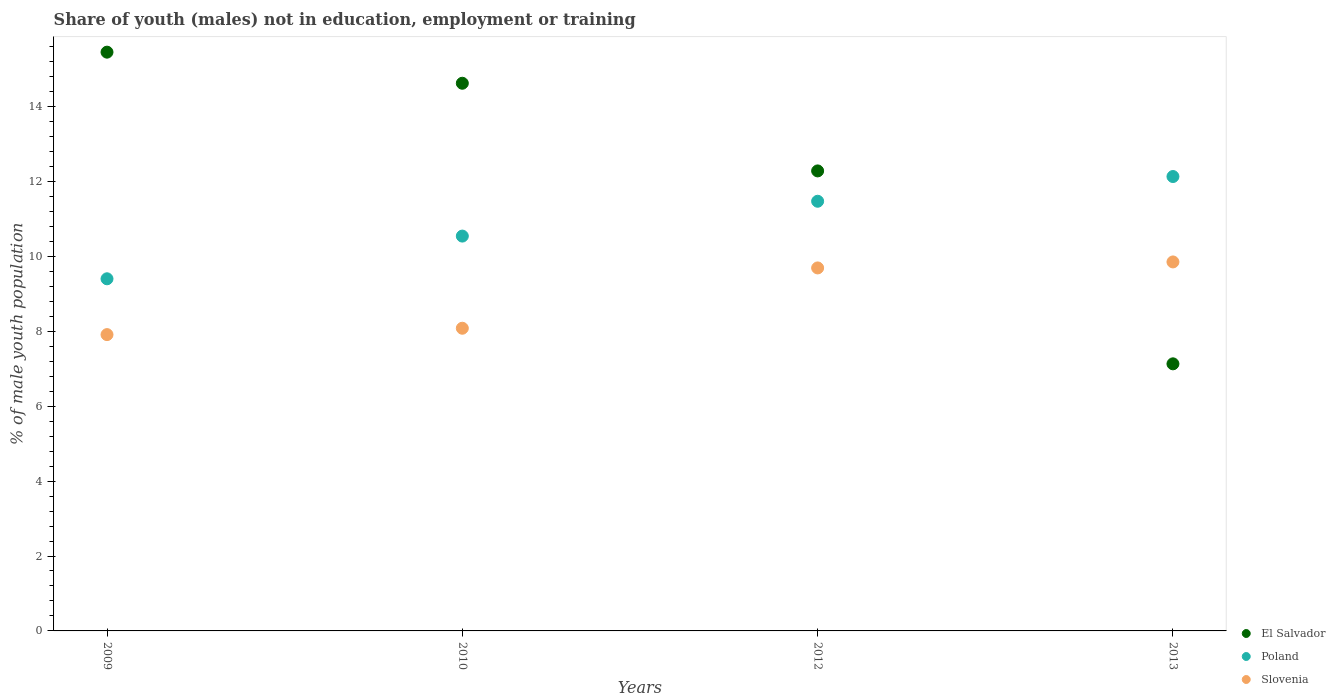Is the number of dotlines equal to the number of legend labels?
Give a very brief answer. Yes. What is the percentage of unemployed males population in in Slovenia in 2009?
Provide a short and direct response. 7.91. Across all years, what is the maximum percentage of unemployed males population in in Slovenia?
Provide a short and direct response. 9.85. Across all years, what is the minimum percentage of unemployed males population in in El Salvador?
Make the answer very short. 7.13. In which year was the percentage of unemployed males population in in Slovenia maximum?
Provide a short and direct response. 2013. In which year was the percentage of unemployed males population in in Poland minimum?
Your response must be concise. 2009. What is the total percentage of unemployed males population in in El Salvador in the graph?
Make the answer very short. 49.48. What is the difference between the percentage of unemployed males population in in Poland in 2009 and that in 2010?
Provide a short and direct response. -1.14. What is the difference between the percentage of unemployed males population in in Poland in 2013 and the percentage of unemployed males population in in El Salvador in 2009?
Your answer should be very brief. -3.32. What is the average percentage of unemployed males population in in El Salvador per year?
Your response must be concise. 12.37. In the year 2012, what is the difference between the percentage of unemployed males population in in Slovenia and percentage of unemployed males population in in Poland?
Your answer should be compact. -1.78. In how many years, is the percentage of unemployed males population in in Slovenia greater than 10.4 %?
Your answer should be compact. 0. What is the ratio of the percentage of unemployed males population in in Poland in 2010 to that in 2013?
Provide a short and direct response. 0.87. Is the percentage of unemployed males population in in Slovenia in 2010 less than that in 2012?
Give a very brief answer. Yes. What is the difference between the highest and the second highest percentage of unemployed males population in in Poland?
Offer a terse response. 0.66. What is the difference between the highest and the lowest percentage of unemployed males population in in Slovenia?
Provide a short and direct response. 1.94. In how many years, is the percentage of unemployed males population in in Slovenia greater than the average percentage of unemployed males population in in Slovenia taken over all years?
Make the answer very short. 2. Is the sum of the percentage of unemployed males population in in El Salvador in 2010 and 2012 greater than the maximum percentage of unemployed males population in in Poland across all years?
Make the answer very short. Yes. Is it the case that in every year, the sum of the percentage of unemployed males population in in Poland and percentage of unemployed males population in in Slovenia  is greater than the percentage of unemployed males population in in El Salvador?
Keep it short and to the point. Yes. Is the percentage of unemployed males population in in El Salvador strictly greater than the percentage of unemployed males population in in Poland over the years?
Your response must be concise. No. What is the difference between two consecutive major ticks on the Y-axis?
Make the answer very short. 2. Does the graph contain any zero values?
Keep it short and to the point. No. How many legend labels are there?
Offer a terse response. 3. How are the legend labels stacked?
Your answer should be very brief. Vertical. What is the title of the graph?
Your answer should be very brief. Share of youth (males) not in education, employment or training. What is the label or title of the Y-axis?
Offer a very short reply. % of male youth population. What is the % of male youth population of El Salvador in 2009?
Provide a succinct answer. 15.45. What is the % of male youth population in Poland in 2009?
Keep it short and to the point. 9.4. What is the % of male youth population in Slovenia in 2009?
Ensure brevity in your answer.  7.91. What is the % of male youth population in El Salvador in 2010?
Provide a succinct answer. 14.62. What is the % of male youth population of Poland in 2010?
Offer a terse response. 10.54. What is the % of male youth population in Slovenia in 2010?
Provide a succinct answer. 8.08. What is the % of male youth population of El Salvador in 2012?
Ensure brevity in your answer.  12.28. What is the % of male youth population of Poland in 2012?
Ensure brevity in your answer.  11.47. What is the % of male youth population in Slovenia in 2012?
Your answer should be very brief. 9.69. What is the % of male youth population of El Salvador in 2013?
Your response must be concise. 7.13. What is the % of male youth population in Poland in 2013?
Your response must be concise. 12.13. What is the % of male youth population in Slovenia in 2013?
Offer a very short reply. 9.85. Across all years, what is the maximum % of male youth population in El Salvador?
Give a very brief answer. 15.45. Across all years, what is the maximum % of male youth population in Poland?
Make the answer very short. 12.13. Across all years, what is the maximum % of male youth population in Slovenia?
Your answer should be compact. 9.85. Across all years, what is the minimum % of male youth population in El Salvador?
Your response must be concise. 7.13. Across all years, what is the minimum % of male youth population in Poland?
Provide a succinct answer. 9.4. Across all years, what is the minimum % of male youth population in Slovenia?
Your response must be concise. 7.91. What is the total % of male youth population of El Salvador in the graph?
Make the answer very short. 49.48. What is the total % of male youth population of Poland in the graph?
Offer a terse response. 43.54. What is the total % of male youth population in Slovenia in the graph?
Ensure brevity in your answer.  35.53. What is the difference between the % of male youth population of El Salvador in 2009 and that in 2010?
Provide a succinct answer. 0.83. What is the difference between the % of male youth population of Poland in 2009 and that in 2010?
Keep it short and to the point. -1.14. What is the difference between the % of male youth population in Slovenia in 2009 and that in 2010?
Make the answer very short. -0.17. What is the difference between the % of male youth population in El Salvador in 2009 and that in 2012?
Your answer should be compact. 3.17. What is the difference between the % of male youth population of Poland in 2009 and that in 2012?
Give a very brief answer. -2.07. What is the difference between the % of male youth population in Slovenia in 2009 and that in 2012?
Offer a very short reply. -1.78. What is the difference between the % of male youth population of El Salvador in 2009 and that in 2013?
Provide a succinct answer. 8.32. What is the difference between the % of male youth population in Poland in 2009 and that in 2013?
Provide a succinct answer. -2.73. What is the difference between the % of male youth population in Slovenia in 2009 and that in 2013?
Offer a very short reply. -1.94. What is the difference between the % of male youth population in El Salvador in 2010 and that in 2012?
Offer a very short reply. 2.34. What is the difference between the % of male youth population in Poland in 2010 and that in 2012?
Offer a very short reply. -0.93. What is the difference between the % of male youth population in Slovenia in 2010 and that in 2012?
Offer a very short reply. -1.61. What is the difference between the % of male youth population of El Salvador in 2010 and that in 2013?
Your answer should be compact. 7.49. What is the difference between the % of male youth population in Poland in 2010 and that in 2013?
Ensure brevity in your answer.  -1.59. What is the difference between the % of male youth population in Slovenia in 2010 and that in 2013?
Keep it short and to the point. -1.77. What is the difference between the % of male youth population in El Salvador in 2012 and that in 2013?
Keep it short and to the point. 5.15. What is the difference between the % of male youth population in Poland in 2012 and that in 2013?
Make the answer very short. -0.66. What is the difference between the % of male youth population in Slovenia in 2012 and that in 2013?
Your answer should be compact. -0.16. What is the difference between the % of male youth population of El Salvador in 2009 and the % of male youth population of Poland in 2010?
Ensure brevity in your answer.  4.91. What is the difference between the % of male youth population in El Salvador in 2009 and the % of male youth population in Slovenia in 2010?
Ensure brevity in your answer.  7.37. What is the difference between the % of male youth population of Poland in 2009 and the % of male youth population of Slovenia in 2010?
Offer a very short reply. 1.32. What is the difference between the % of male youth population of El Salvador in 2009 and the % of male youth population of Poland in 2012?
Your answer should be compact. 3.98. What is the difference between the % of male youth population of El Salvador in 2009 and the % of male youth population of Slovenia in 2012?
Offer a very short reply. 5.76. What is the difference between the % of male youth population of Poland in 2009 and the % of male youth population of Slovenia in 2012?
Provide a succinct answer. -0.29. What is the difference between the % of male youth population in El Salvador in 2009 and the % of male youth population in Poland in 2013?
Your answer should be compact. 3.32. What is the difference between the % of male youth population in Poland in 2009 and the % of male youth population in Slovenia in 2013?
Give a very brief answer. -0.45. What is the difference between the % of male youth population in El Salvador in 2010 and the % of male youth population in Poland in 2012?
Give a very brief answer. 3.15. What is the difference between the % of male youth population of El Salvador in 2010 and the % of male youth population of Slovenia in 2012?
Offer a very short reply. 4.93. What is the difference between the % of male youth population of El Salvador in 2010 and the % of male youth population of Poland in 2013?
Give a very brief answer. 2.49. What is the difference between the % of male youth population of El Salvador in 2010 and the % of male youth population of Slovenia in 2013?
Give a very brief answer. 4.77. What is the difference between the % of male youth population of Poland in 2010 and the % of male youth population of Slovenia in 2013?
Your answer should be compact. 0.69. What is the difference between the % of male youth population in El Salvador in 2012 and the % of male youth population in Poland in 2013?
Provide a short and direct response. 0.15. What is the difference between the % of male youth population in El Salvador in 2012 and the % of male youth population in Slovenia in 2013?
Make the answer very short. 2.43. What is the difference between the % of male youth population in Poland in 2012 and the % of male youth population in Slovenia in 2013?
Provide a short and direct response. 1.62. What is the average % of male youth population of El Salvador per year?
Your response must be concise. 12.37. What is the average % of male youth population of Poland per year?
Make the answer very short. 10.88. What is the average % of male youth population of Slovenia per year?
Ensure brevity in your answer.  8.88. In the year 2009, what is the difference between the % of male youth population of El Salvador and % of male youth population of Poland?
Your answer should be compact. 6.05. In the year 2009, what is the difference between the % of male youth population of El Salvador and % of male youth population of Slovenia?
Offer a terse response. 7.54. In the year 2009, what is the difference between the % of male youth population of Poland and % of male youth population of Slovenia?
Provide a short and direct response. 1.49. In the year 2010, what is the difference between the % of male youth population of El Salvador and % of male youth population of Poland?
Your answer should be compact. 4.08. In the year 2010, what is the difference between the % of male youth population in El Salvador and % of male youth population in Slovenia?
Your response must be concise. 6.54. In the year 2010, what is the difference between the % of male youth population in Poland and % of male youth population in Slovenia?
Ensure brevity in your answer.  2.46. In the year 2012, what is the difference between the % of male youth population in El Salvador and % of male youth population in Poland?
Give a very brief answer. 0.81. In the year 2012, what is the difference between the % of male youth population in El Salvador and % of male youth population in Slovenia?
Offer a very short reply. 2.59. In the year 2012, what is the difference between the % of male youth population in Poland and % of male youth population in Slovenia?
Your response must be concise. 1.78. In the year 2013, what is the difference between the % of male youth population in El Salvador and % of male youth population in Poland?
Provide a short and direct response. -5. In the year 2013, what is the difference between the % of male youth population in El Salvador and % of male youth population in Slovenia?
Offer a terse response. -2.72. In the year 2013, what is the difference between the % of male youth population in Poland and % of male youth population in Slovenia?
Ensure brevity in your answer.  2.28. What is the ratio of the % of male youth population of El Salvador in 2009 to that in 2010?
Ensure brevity in your answer.  1.06. What is the ratio of the % of male youth population of Poland in 2009 to that in 2010?
Your response must be concise. 0.89. What is the ratio of the % of male youth population in El Salvador in 2009 to that in 2012?
Provide a succinct answer. 1.26. What is the ratio of the % of male youth population of Poland in 2009 to that in 2012?
Keep it short and to the point. 0.82. What is the ratio of the % of male youth population in Slovenia in 2009 to that in 2012?
Offer a terse response. 0.82. What is the ratio of the % of male youth population of El Salvador in 2009 to that in 2013?
Your response must be concise. 2.17. What is the ratio of the % of male youth population in Poland in 2009 to that in 2013?
Your answer should be very brief. 0.77. What is the ratio of the % of male youth population in Slovenia in 2009 to that in 2013?
Make the answer very short. 0.8. What is the ratio of the % of male youth population of El Salvador in 2010 to that in 2012?
Provide a short and direct response. 1.19. What is the ratio of the % of male youth population of Poland in 2010 to that in 2012?
Give a very brief answer. 0.92. What is the ratio of the % of male youth population in Slovenia in 2010 to that in 2012?
Ensure brevity in your answer.  0.83. What is the ratio of the % of male youth population in El Salvador in 2010 to that in 2013?
Ensure brevity in your answer.  2.05. What is the ratio of the % of male youth population in Poland in 2010 to that in 2013?
Give a very brief answer. 0.87. What is the ratio of the % of male youth population in Slovenia in 2010 to that in 2013?
Provide a succinct answer. 0.82. What is the ratio of the % of male youth population of El Salvador in 2012 to that in 2013?
Give a very brief answer. 1.72. What is the ratio of the % of male youth population of Poland in 2012 to that in 2013?
Provide a succinct answer. 0.95. What is the ratio of the % of male youth population of Slovenia in 2012 to that in 2013?
Offer a terse response. 0.98. What is the difference between the highest and the second highest % of male youth population of El Salvador?
Your answer should be compact. 0.83. What is the difference between the highest and the second highest % of male youth population of Poland?
Provide a short and direct response. 0.66. What is the difference between the highest and the second highest % of male youth population in Slovenia?
Offer a very short reply. 0.16. What is the difference between the highest and the lowest % of male youth population in El Salvador?
Provide a succinct answer. 8.32. What is the difference between the highest and the lowest % of male youth population of Poland?
Your response must be concise. 2.73. What is the difference between the highest and the lowest % of male youth population of Slovenia?
Give a very brief answer. 1.94. 